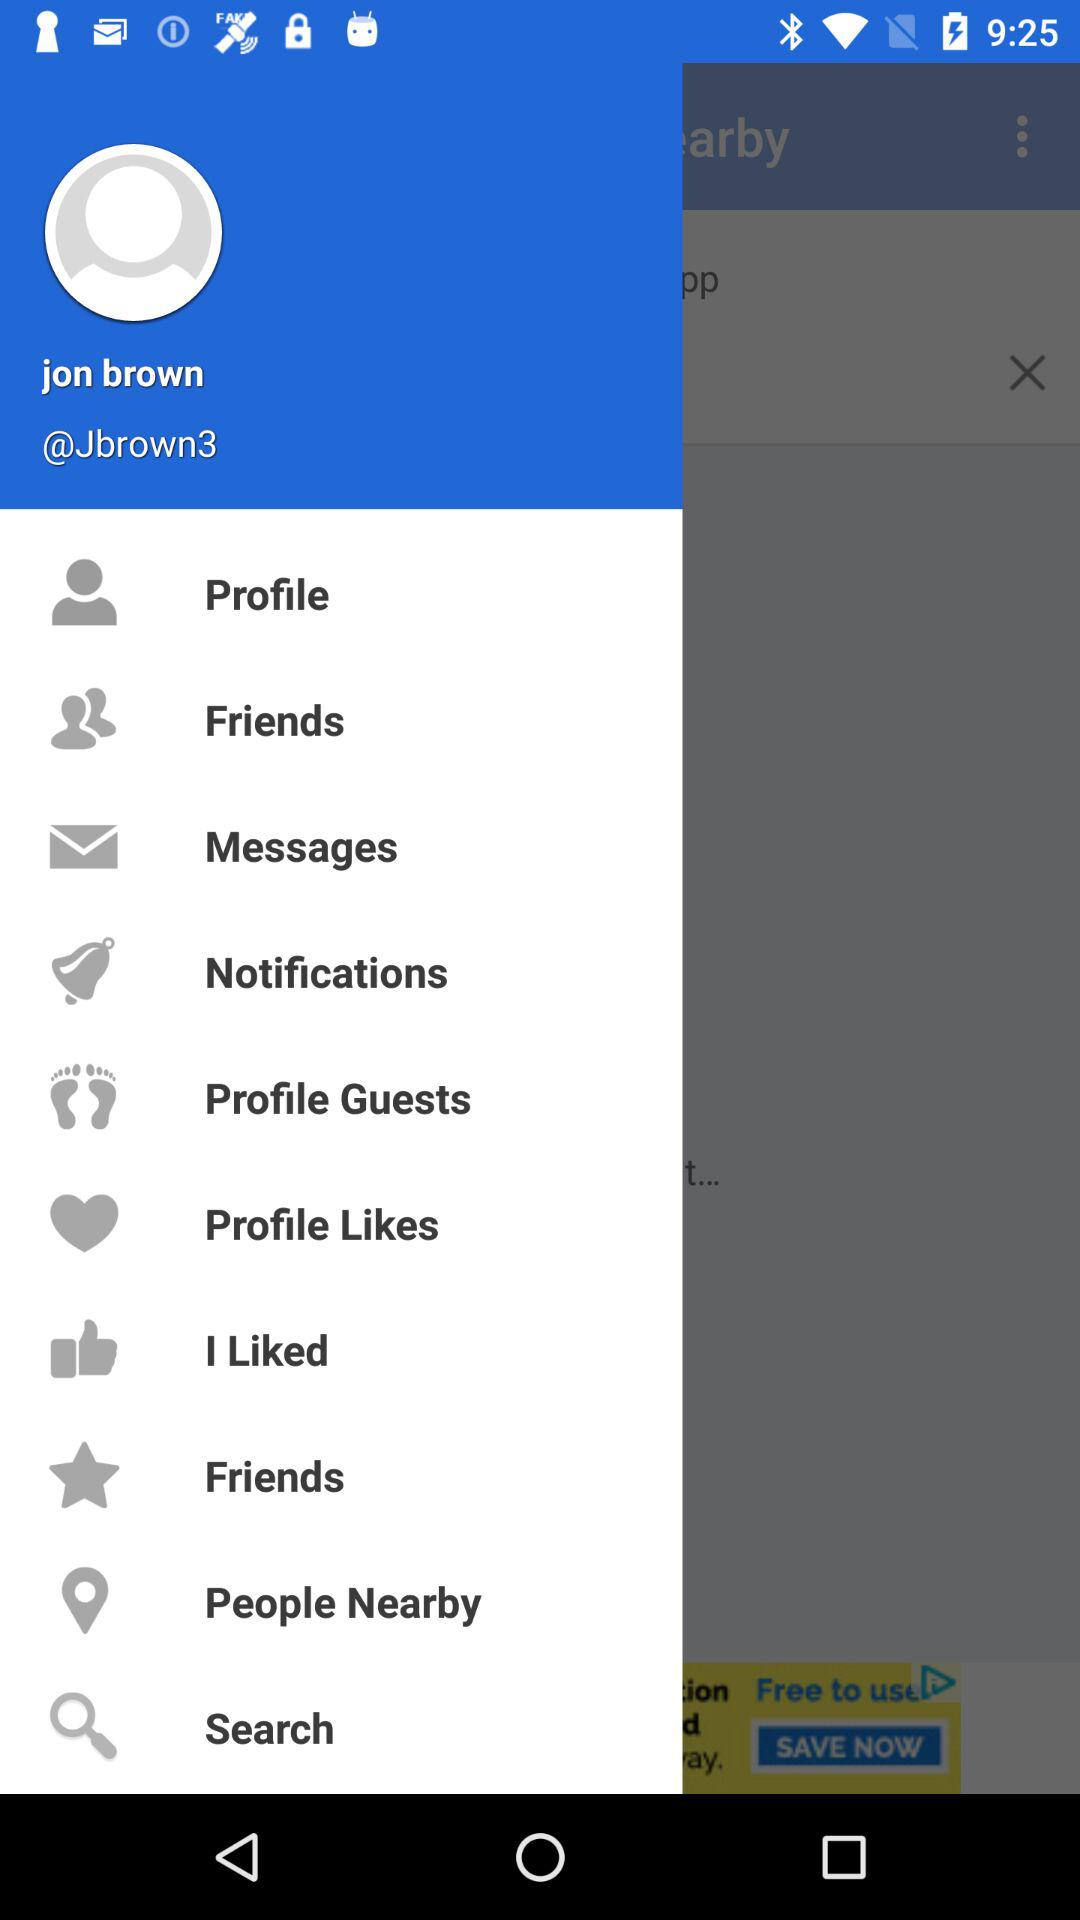What is the user name? The user name is Jon Brown. 